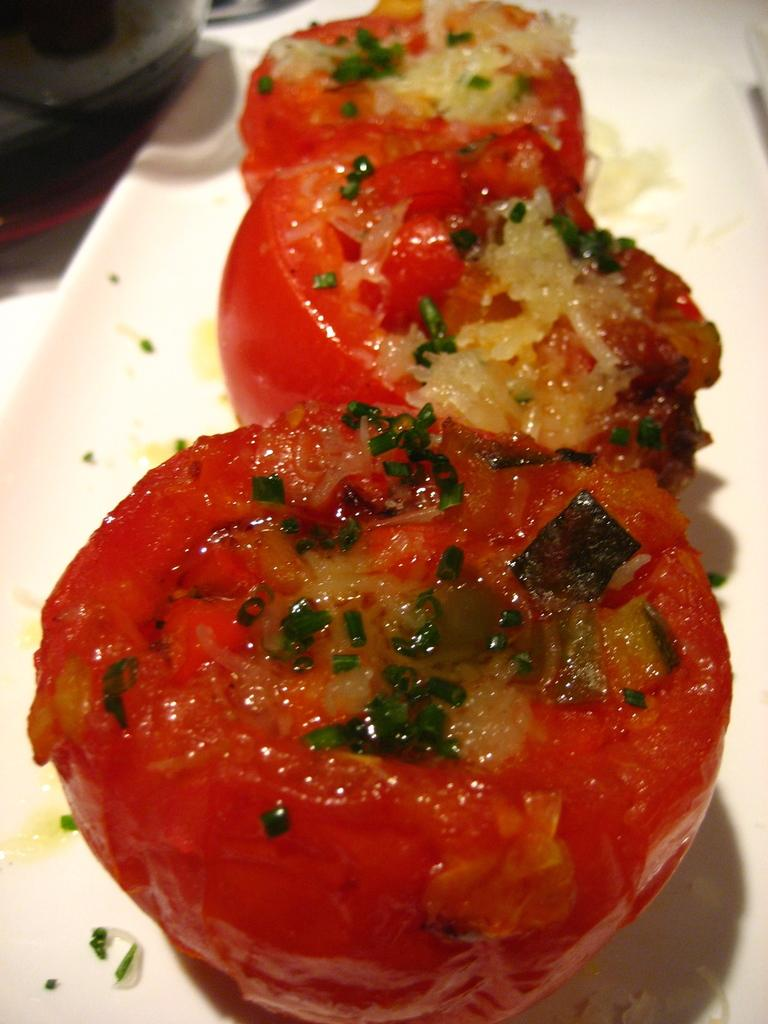What type of food can be seen in the image? There are pieces of plum tomatoes in the image. Where are the plum tomatoes located? The plum tomatoes are in a plate. What type of tool is being used to tighten the coil in the image? There is no tool or coil present in the image; it only features pieces of plum tomatoes in a plate. 